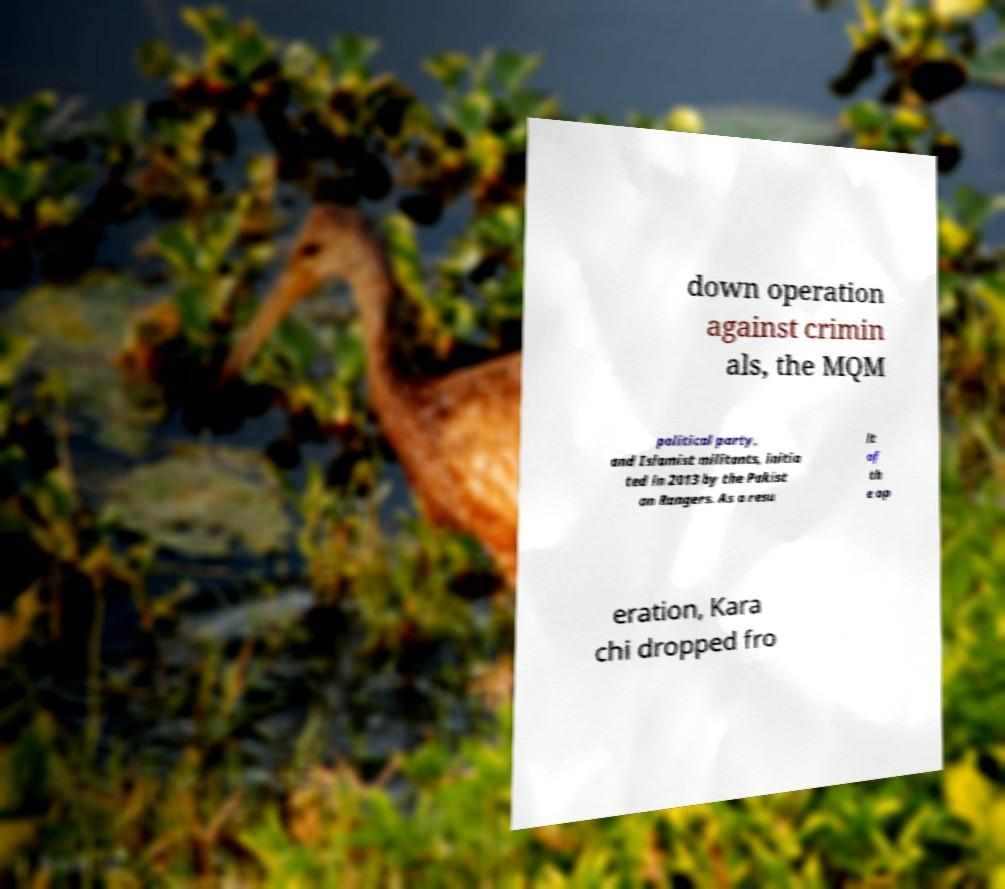There's text embedded in this image that I need extracted. Can you transcribe it verbatim? down operation against crimin als, the MQM political party, and Islamist militants, initia ted in 2013 by the Pakist an Rangers. As a resu lt of th e op eration, Kara chi dropped fro 